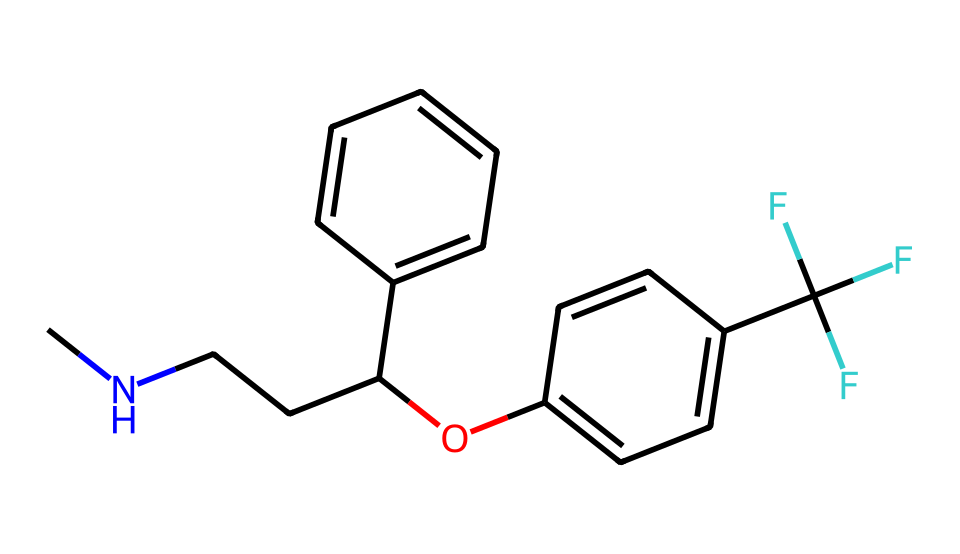What is the functional group present in this antidepressant? The SMILES notation includes "Oc", indicating the hydroxyl group (-OH), which is a functional group commonly found in alcohols and phenols.
Answer: hydroxyl group How many carbon atoms are in this chemical? By analyzing the SMILES representation, we can count the carbon atoms appearing in various parts of the structure. There are 15 carbon atoms present in total.
Answer: 15 What is the molecular notation for this antidepressant? The provided SMILES code can be translated to its corresponding molecular formula, which considers the number of each type of atom present. The molecular formula is C15H18F3N1O1.
Answer: C15H18F3N1O1 Does the molecule contain any fluorine atoms? The presence of "F" in the SMILES indicates the inclusion of fluorine atoms in the structure. Counting the 'F' shows that there are 3 fluorine atoms.
Answer: 3 What type of bonding can be inferred from the structure? Analyzing the representation reveals multiple types of bonds, particularly the presence of carbon-carbon (C-C), carbon-nitrogen (C-N), and carbon-oxygen (C-O) single bonds, as well as some aromatic rings.
Answer: covalent bonding How many rings are found in this molecule? Upon visualizing the structure based on the SMILES, there are two identifiable aromatic rings in the antidepressant molecule that contribute to its rigidity and stability.
Answer: 2 What aspect of this molecule suggests its use as an antidepressant? The presence of nitrogen atoms and a hydroxyl group typically indicates psychoactive properties, as these functional groups are often associated with the pharmacodynamics of antidepressants.
Answer: nitrogen and hydroxyl groups 